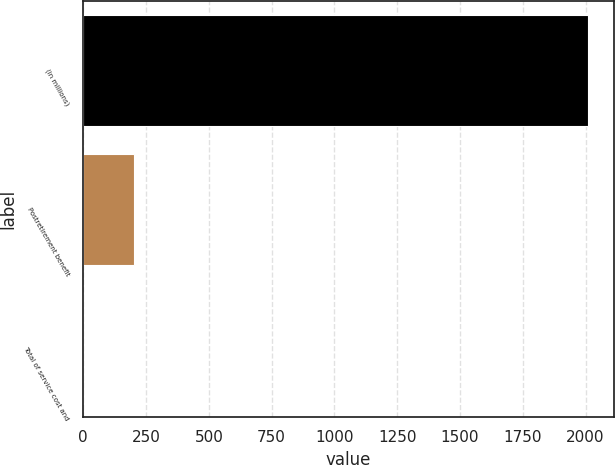<chart> <loc_0><loc_0><loc_500><loc_500><bar_chart><fcel>(in millions)<fcel>Postretirement benefit<fcel>Total of service cost and<nl><fcel>2011<fcel>201.28<fcel>0.2<nl></chart> 